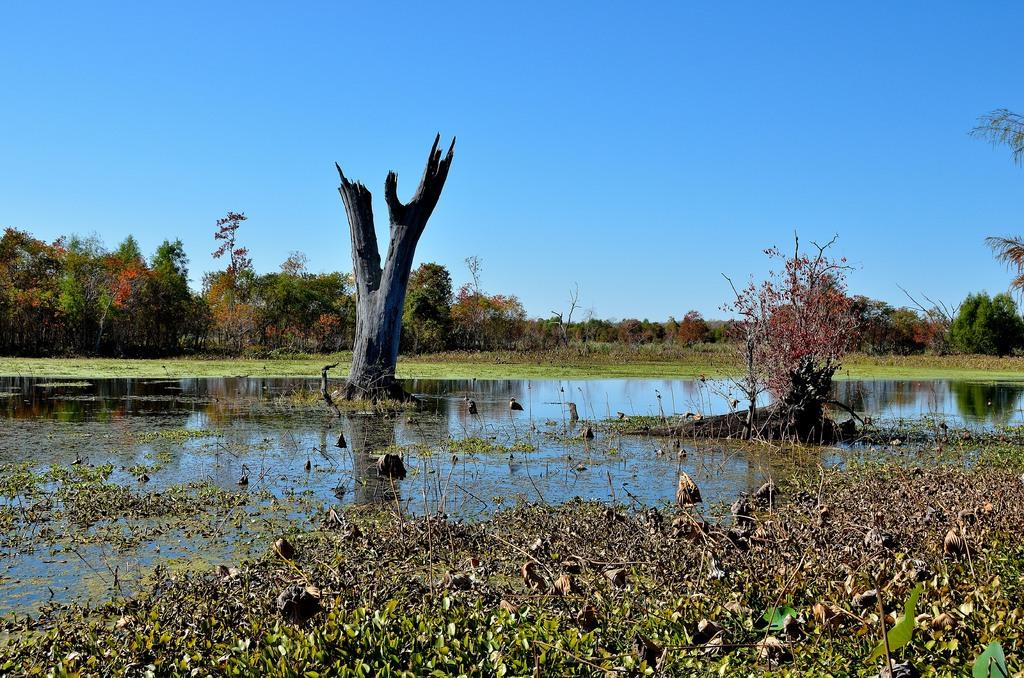What is the primary element visible in the image? There is water in the image. What type of vegetation can be seen at the bottom of the image? There is grass visible at the bottom of the image. What can be seen in the background of the image? There are trees in the background of the image. What is visible at the top of the image? The sky is visible at the top of the image. How many bears can be seen playing in the water in the image? There are no bears present in the image; it features water, grass, trees, and the sky. Is there a tiger visible in the grass at the bottom of the image? There is no tiger present in the image; it only features grass, water, trees, and the sky. 